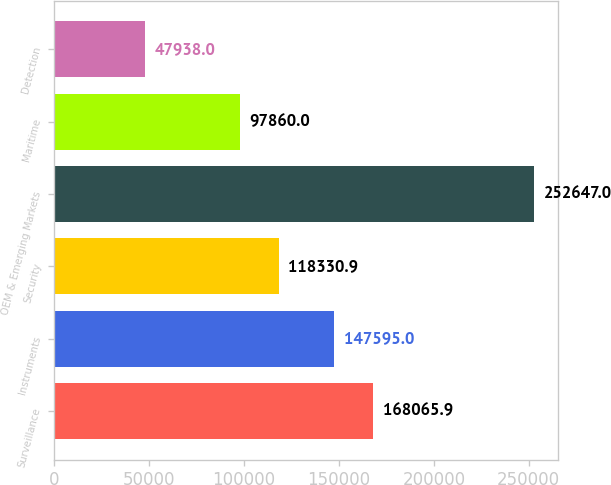<chart> <loc_0><loc_0><loc_500><loc_500><bar_chart><fcel>Surveillance<fcel>Instruments<fcel>Security<fcel>OEM & Emerging Markets<fcel>Maritime<fcel>Detection<nl><fcel>168066<fcel>147595<fcel>118331<fcel>252647<fcel>97860<fcel>47938<nl></chart> 